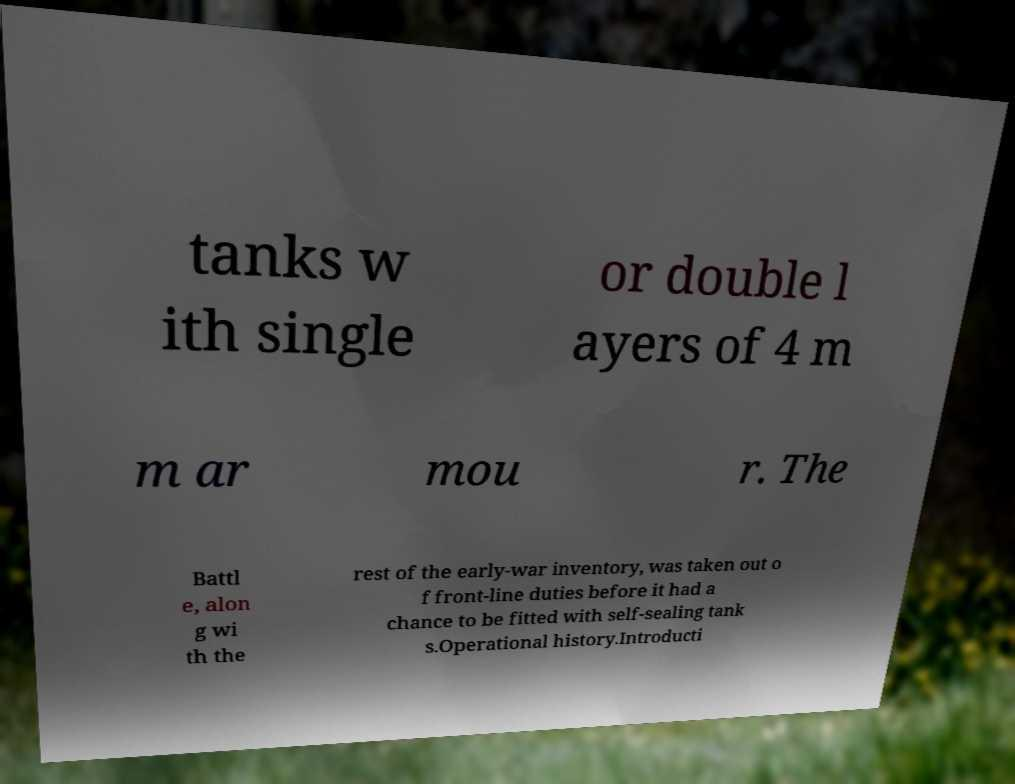Can you accurately transcribe the text from the provided image for me? tanks w ith single or double l ayers of 4 m m ar mou r. The Battl e, alon g wi th the rest of the early-war inventory, was taken out o f front-line duties before it had a chance to be fitted with self-sealing tank s.Operational history.Introducti 